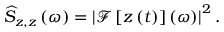Convert formula to latex. <formula><loc_0><loc_0><loc_500><loc_500>\widehat { S } _ { z , z } \left ( \omega \right ) = \left | \mathcal { F } \left [ z \left ( t \right ) \right ] \left ( \omega \right ) \right | ^ { 2 } .</formula> 